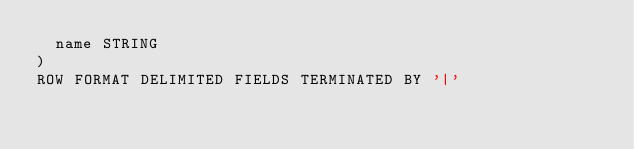<code> <loc_0><loc_0><loc_500><loc_500><_SQL_>  name STRING
)
ROW FORMAT DELIMITED FIELDS TERMINATED BY '|'
</code> 